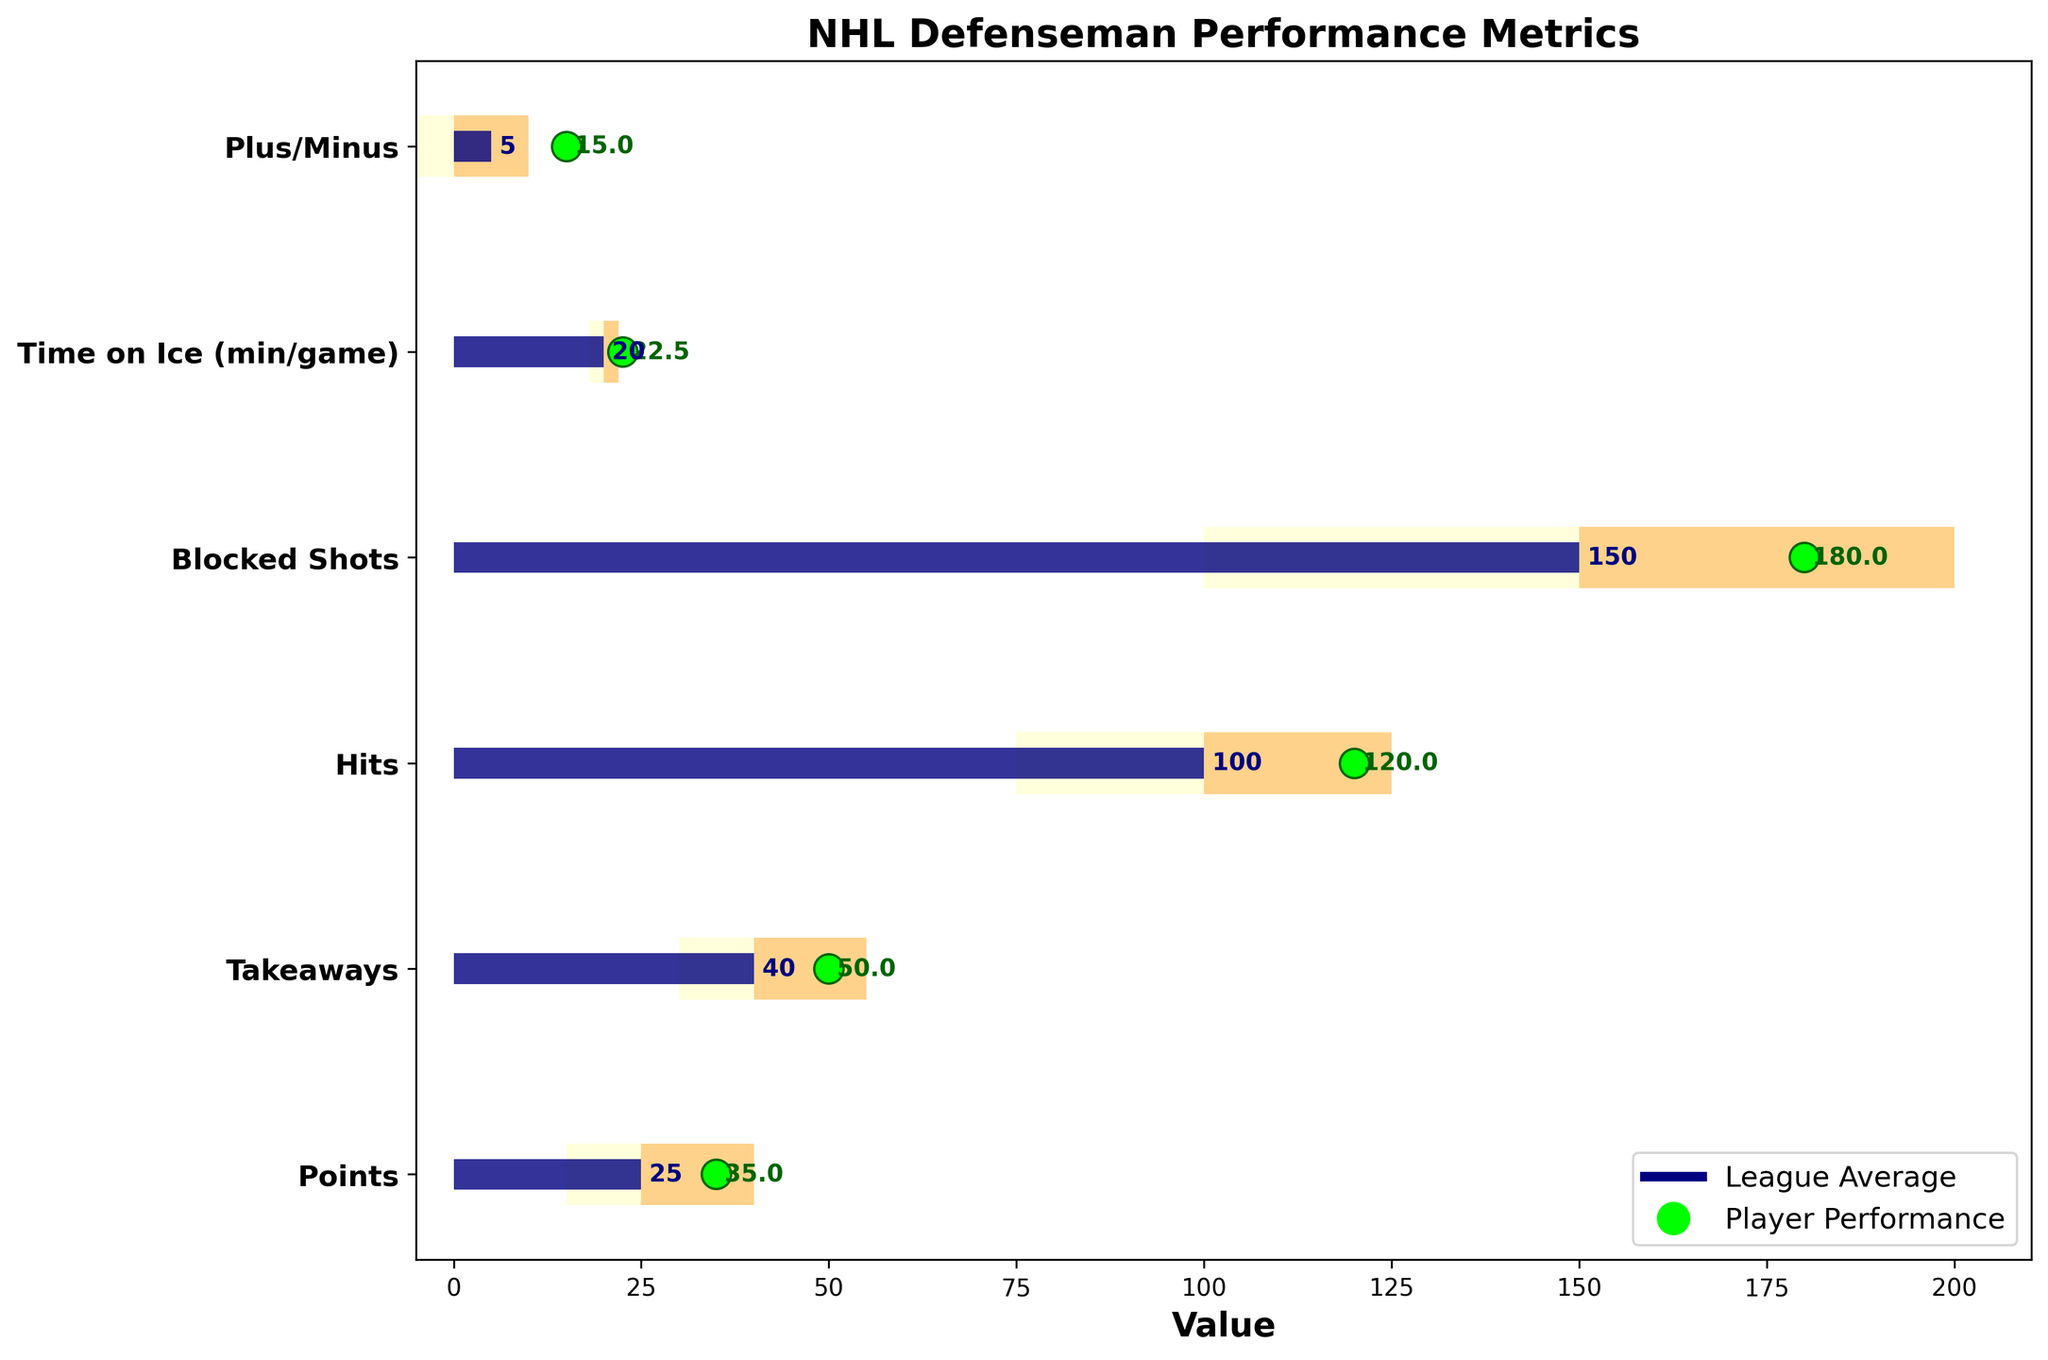Which performance metric has the highest player performance above the league average? The player’s actual value for each metric can be seen with green dots. By comparing the difference between the green dot (player performance) and the blue bar (league average), Plus/Minus has the largest difference.
Answer: Plus/Minus How does the actual performance in blocked shots compare to the range categories? The actual value for blocked shots is 180, which falls within the third range (100–200 being the ranges). This shows that player performance is within the highest range for blocked shots.
Answer: 180, within 100-200 Which metric is closest to the league average value? By observing the blue bars (league averages) and comparing them to the green dots (actual performance), the green dot for Time on Ice is closest to its corresponding blue bar of 20.
Answer: Time on Ice What is the actual value for Points? The green dot for Points on the chart shows an actual performance value. The label near the green dot confirms the value.
Answer: 35 How much more does the player block shots compared to the league average? First, find the actual number of blocked shots (green dot) which is 180. The league average (blue bar) is 150. Subtract 150 from 180.
Answer: 30 How does the player’s Hits performance compare to the second range of categories? The second range for Hits is from 100 to 125, and the player's actual value (green dot) is 120. This falls within the second range.
Answer: 120, within 100-125 What is the difference between the player’s Takeaways and the league average? The Takeaways actual value (green dot) is 50, and the comparative average (blue bar) for the league is 40. Subtract 40 from 50.
Answer: 10 How many metrics are there where the player’s performance exceeds the highest range? Identify metrics where the green dot (actual performance) is higher than the highest value in the category ranges. Points, Plus/Minus, and Blocked Shots are within the highest range but do not exceed it. Thus, no metrics exceed the highest range.
Answer: 0 What is the player’s Plus/Minus value, and how does it compare to the league average? The actual performance (green dot) is 15, while the league average (blue bar) is 5. The player’s Plus/Minus is 10 higher than the average.
Answer: 15, 10 higher than average How consistent is the player across all metrics compared to the league average? By examining the green dots and blue bars, we observe the deviation level for each metric. The player performance significantly exceeds the league average in many metrics, indicating high consistency at a higher-than-average level.
Answer: Consistently higher 